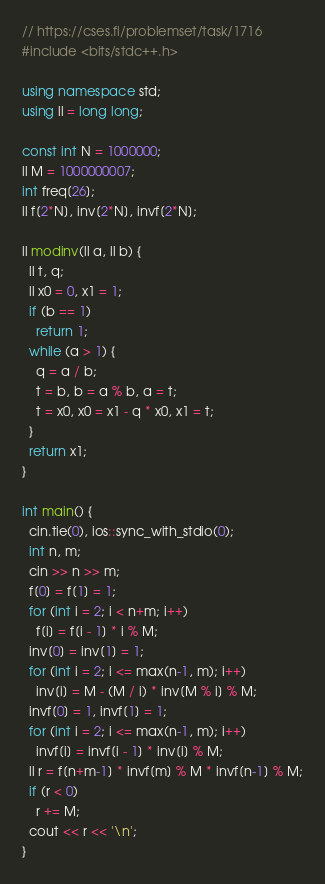Convert code to text. <code><loc_0><loc_0><loc_500><loc_500><_C++_>// https://cses.fi/problemset/task/1716
#include <bits/stdc++.h>

using namespace std;
using ll = long long;

const int N = 1000000;
ll M = 1000000007;
int freq[26];
ll f[2*N], inv[2*N], invf[2*N];

ll modinv(ll a, ll b) {
  ll t, q;
  ll x0 = 0, x1 = 1;
  if (b == 1)
    return 1;
  while (a > 1) {
    q = a / b;
    t = b, b = a % b, a = t;
    t = x0, x0 = x1 - q * x0, x1 = t;
  }
  return x1;
}

int main() {
  cin.tie(0), ios::sync_with_stdio(0);
  int n, m;
  cin >> n >> m;
  f[0] = f[1] = 1;
  for (int i = 2; i < n+m; i++)
    f[i] = f[i - 1] * i % M;
  inv[0] = inv[1] = 1;
  for (int i = 2; i <= max(n-1, m); i++)
    inv[i] = M - (M / i) * inv[M % i] % M;
  invf[0] = 1, invf[1] = 1;
  for (int i = 2; i <= max(n-1, m); i++)
    invf[i] = invf[i - 1] * inv[i] % M;
  ll r = f[n+m-1] * invf[m] % M * invf[n-1] % M;
  if (r < 0)
    r += M;
  cout << r << '\n';
}
</code> 